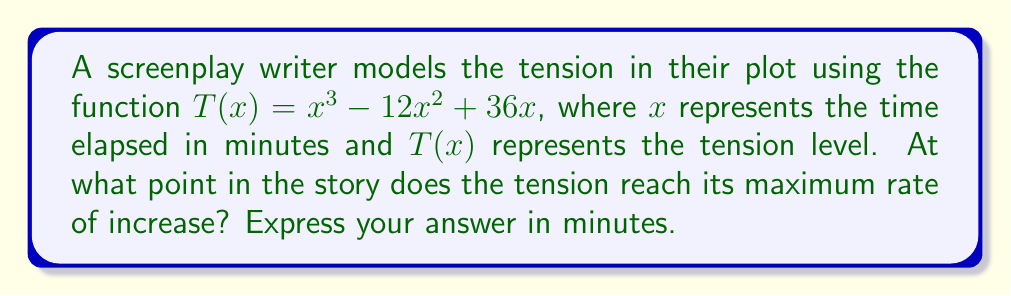Provide a solution to this math problem. To find the point where the tension reaches its maximum rate of increase, we need to follow these steps:

1) The rate of change of tension is given by the first derivative of $T(x)$:
   $$T'(x) = 3x^2 - 24x + 36$$

2) The maximum rate of increase occurs where the second derivative equals zero. Let's find the second derivative:
   $$T''(x) = 6x - 24$$

3) Set the second derivative to zero and solve for x:
   $$6x - 24 = 0$$
   $$6x = 24$$
   $$x = 4$$

4) To confirm this is a maximum (not a minimum) rate of increase, we can check the sign of $T'''(x)$:
   $$T'''(x) = 6$$
   Since this is positive, we confirm that $x = 4$ gives a maximum rate of increase.

5) Therefore, the tension reaches its maximum rate of increase at 4 minutes into the story.

This point could represent a crucial moment in the screenplay where the action or conflict intensifies most rapidly, potentially serving as a key turning point in the plot.
Answer: 4 minutes 